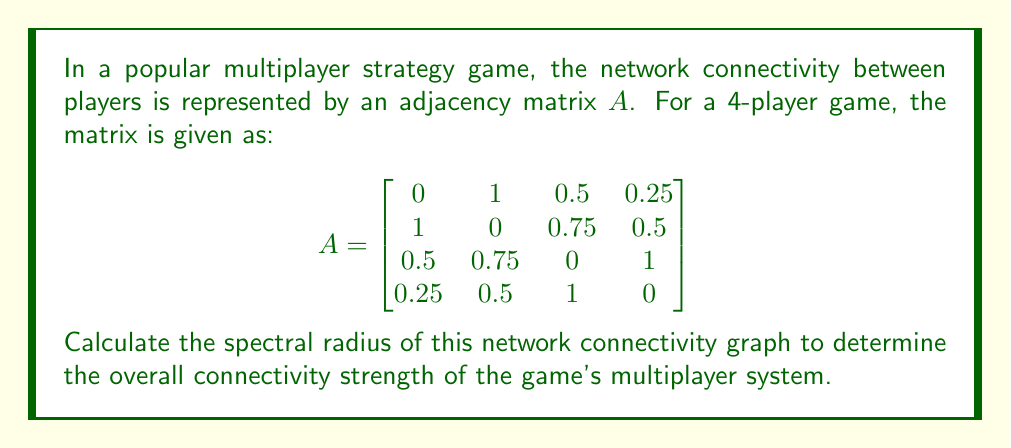Can you solve this math problem? To find the spectral radius of the network connectivity graph, we need to follow these steps:

1) The spectral radius is defined as the largest absolute eigenvalue of the adjacency matrix $A$.

2) To find the eigenvalues, we need to solve the characteristic equation:
   $$\det(A - \lambda I) = 0$$
   where $I$ is the 4x4 identity matrix and $\lambda$ represents the eigenvalues.

3) Expanding this determinant leads to a 4th degree polynomial equation:
   $$\lambda^4 - 2.8125\lambda^2 - 0.359375 = 0$$

4) This is a biquadratic equation. Let $u = \lambda^2$, then we have:
   $$u^2 - 2.8125u - 0.359375 = 0$$

5) Using the quadratic formula, we can solve for $u$:
   $$u = \frac{2.8125 \pm \sqrt{2.8125^2 + 4(0.359375)}}{2}$$

6) This gives us:
   $$u_1 \approx 2.9277 \text{ and } u_2 \approx -0.1152$$

7) Since $u = \lambda^2$, we take the square root to find $\lambda$:
   $$\lambda = \pm\sqrt{2.9277} \text{ and } \pm\sqrt{0.1152}$$

8) The largest absolute value among these is $\sqrt{2.9277} \approx 1.7110$

Therefore, the spectral radius of the network connectivity graph is approximately 1.7110.
Answer: 1.7110 